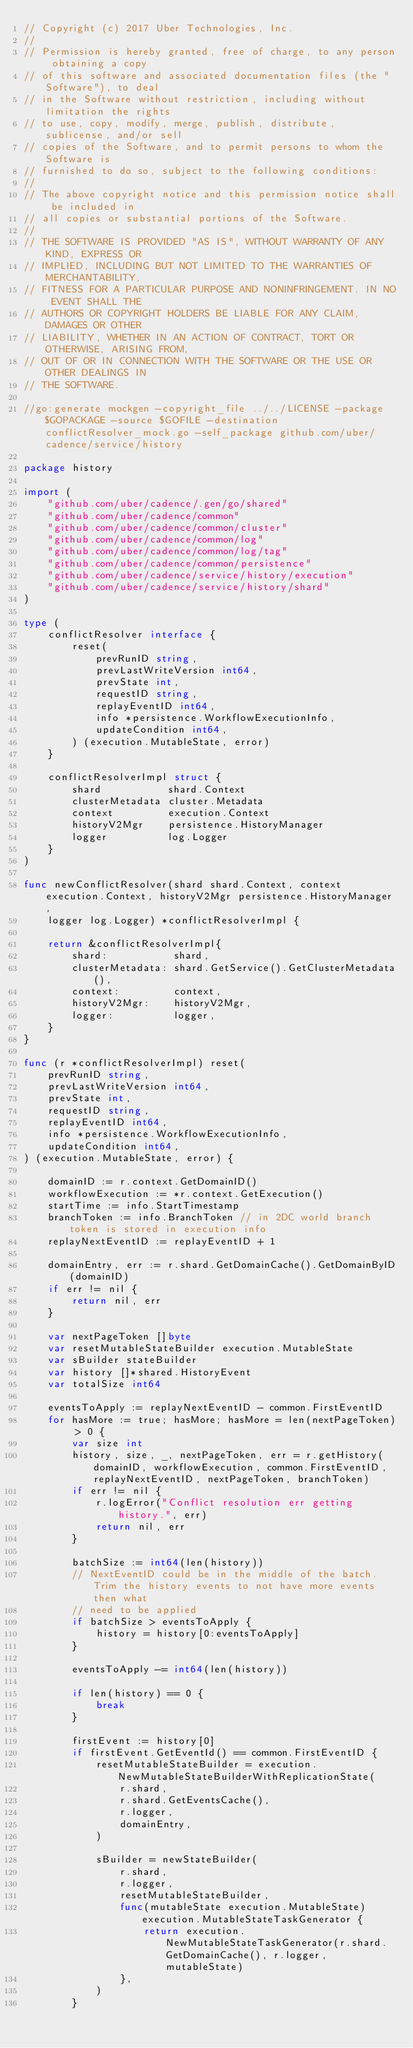Convert code to text. <code><loc_0><loc_0><loc_500><loc_500><_Go_>// Copyright (c) 2017 Uber Technologies, Inc.
//
// Permission is hereby granted, free of charge, to any person obtaining a copy
// of this software and associated documentation files (the "Software"), to deal
// in the Software without restriction, including without limitation the rights
// to use, copy, modify, merge, publish, distribute, sublicense, and/or sell
// copies of the Software, and to permit persons to whom the Software is
// furnished to do so, subject to the following conditions:
//
// The above copyright notice and this permission notice shall be included in
// all copies or substantial portions of the Software.
//
// THE SOFTWARE IS PROVIDED "AS IS", WITHOUT WARRANTY OF ANY KIND, EXPRESS OR
// IMPLIED, INCLUDING BUT NOT LIMITED TO THE WARRANTIES OF MERCHANTABILITY,
// FITNESS FOR A PARTICULAR PURPOSE AND NONINFRINGEMENT. IN NO EVENT SHALL THE
// AUTHORS OR COPYRIGHT HOLDERS BE LIABLE FOR ANY CLAIM, DAMAGES OR OTHER
// LIABILITY, WHETHER IN AN ACTION OF CONTRACT, TORT OR OTHERWISE, ARISING FROM,
// OUT OF OR IN CONNECTION WITH THE SOFTWARE OR THE USE OR OTHER DEALINGS IN
// THE SOFTWARE.

//go:generate mockgen -copyright_file ../../LICENSE -package $GOPACKAGE -source $GOFILE -destination conflictResolver_mock.go -self_package github.com/uber/cadence/service/history

package history

import (
	"github.com/uber/cadence/.gen/go/shared"
	"github.com/uber/cadence/common"
	"github.com/uber/cadence/common/cluster"
	"github.com/uber/cadence/common/log"
	"github.com/uber/cadence/common/log/tag"
	"github.com/uber/cadence/common/persistence"
	"github.com/uber/cadence/service/history/execution"
	"github.com/uber/cadence/service/history/shard"
)

type (
	conflictResolver interface {
		reset(
			prevRunID string,
			prevLastWriteVersion int64,
			prevState int,
			requestID string,
			replayEventID int64,
			info *persistence.WorkflowExecutionInfo,
			updateCondition int64,
		) (execution.MutableState, error)
	}

	conflictResolverImpl struct {
		shard           shard.Context
		clusterMetadata cluster.Metadata
		context         execution.Context
		historyV2Mgr    persistence.HistoryManager
		logger          log.Logger
	}
)

func newConflictResolver(shard shard.Context, context execution.Context, historyV2Mgr persistence.HistoryManager,
	logger log.Logger) *conflictResolverImpl {

	return &conflictResolverImpl{
		shard:           shard,
		clusterMetadata: shard.GetService().GetClusterMetadata(),
		context:         context,
		historyV2Mgr:    historyV2Mgr,
		logger:          logger,
	}
}

func (r *conflictResolverImpl) reset(
	prevRunID string,
	prevLastWriteVersion int64,
	prevState int,
	requestID string,
	replayEventID int64,
	info *persistence.WorkflowExecutionInfo,
	updateCondition int64,
) (execution.MutableState, error) {

	domainID := r.context.GetDomainID()
	workflowExecution := *r.context.GetExecution()
	startTime := info.StartTimestamp
	branchToken := info.BranchToken // in 2DC world branch token is stored in execution info
	replayNextEventID := replayEventID + 1

	domainEntry, err := r.shard.GetDomainCache().GetDomainByID(domainID)
	if err != nil {
		return nil, err
	}

	var nextPageToken []byte
	var resetMutableStateBuilder execution.MutableState
	var sBuilder stateBuilder
	var history []*shared.HistoryEvent
	var totalSize int64

	eventsToApply := replayNextEventID - common.FirstEventID
	for hasMore := true; hasMore; hasMore = len(nextPageToken) > 0 {
		var size int
		history, size, _, nextPageToken, err = r.getHistory(domainID, workflowExecution, common.FirstEventID, replayNextEventID, nextPageToken, branchToken)
		if err != nil {
			r.logError("Conflict resolution err getting history.", err)
			return nil, err
		}

		batchSize := int64(len(history))
		// NextEventID could be in the middle of the batch.  Trim the history events to not have more events then what
		// need to be applied
		if batchSize > eventsToApply {
			history = history[0:eventsToApply]
		}

		eventsToApply -= int64(len(history))

		if len(history) == 0 {
			break
		}

		firstEvent := history[0]
		if firstEvent.GetEventId() == common.FirstEventID {
			resetMutableStateBuilder = execution.NewMutableStateBuilderWithReplicationState(
				r.shard,
				r.shard.GetEventsCache(),
				r.logger,
				domainEntry,
			)

			sBuilder = newStateBuilder(
				r.shard,
				r.logger,
				resetMutableStateBuilder,
				func(mutableState execution.MutableState) execution.MutableStateTaskGenerator {
					return execution.NewMutableStateTaskGenerator(r.shard.GetDomainCache(), r.logger, mutableState)
				},
			)
		}
</code> 